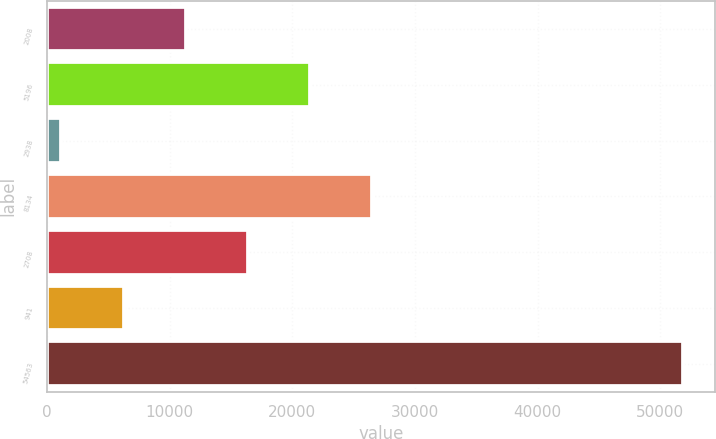Convert chart. <chart><loc_0><loc_0><loc_500><loc_500><bar_chart><fcel>2008<fcel>5196<fcel>2938<fcel>8134<fcel>2708<fcel>941<fcel>54563<nl><fcel>11304.4<fcel>21448.8<fcel>1160<fcel>26521<fcel>16376.6<fcel>6232.2<fcel>51882<nl></chart> 